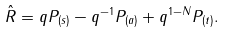<formula> <loc_0><loc_0><loc_500><loc_500>\hat { R } = q P _ { ( s ) } - q ^ { - 1 } P _ { ( a ) } + q ^ { 1 - N } P _ { ( t ) } .</formula> 